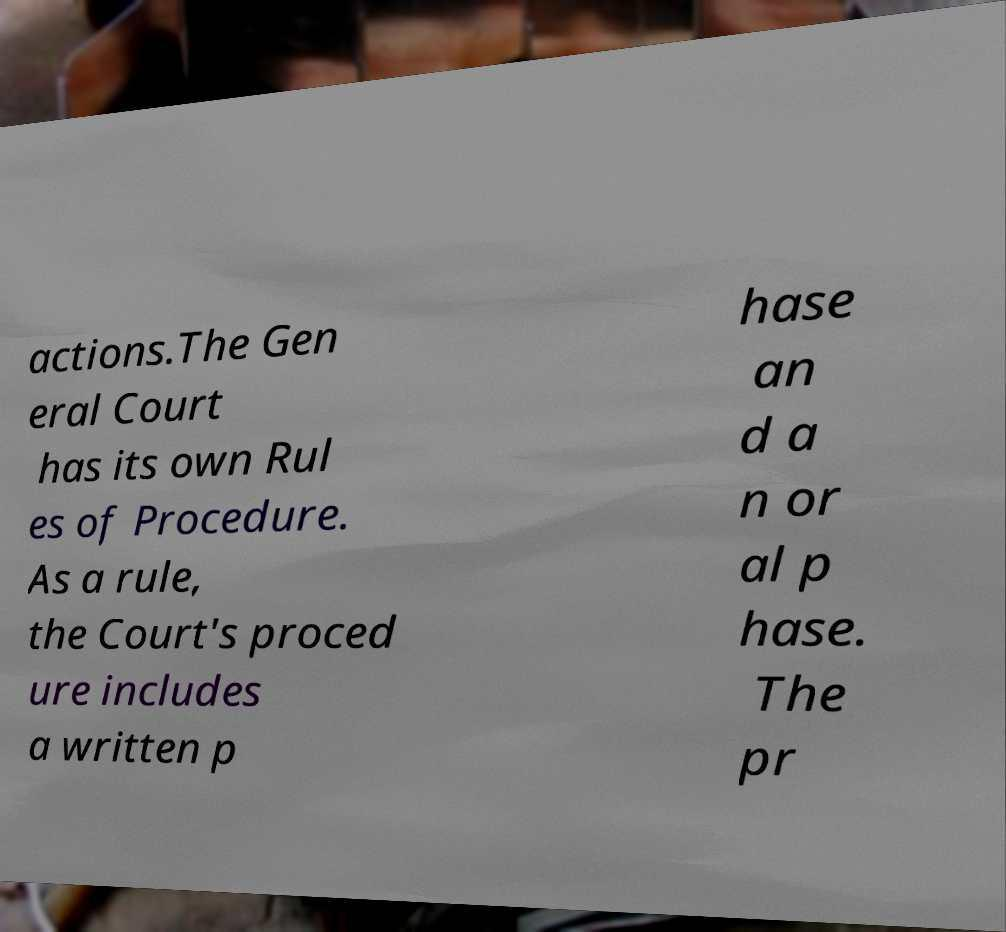Please read and relay the text visible in this image. What does it say? actions.The Gen eral Court has its own Rul es of Procedure. As a rule, the Court's proced ure includes a written p hase an d a n or al p hase. The pr 